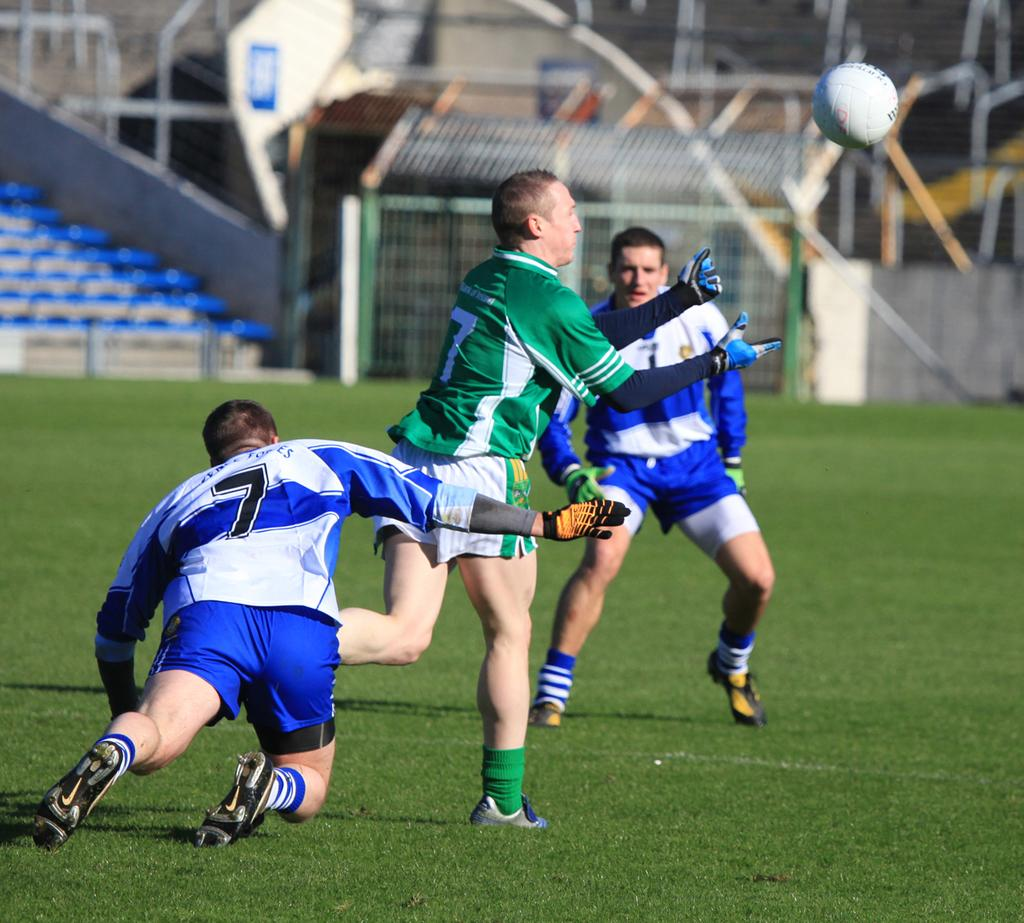<image>
Write a terse but informative summary of the picture. The goalkeeper who wears number 7 in green prepares to catch a soccer ball. 